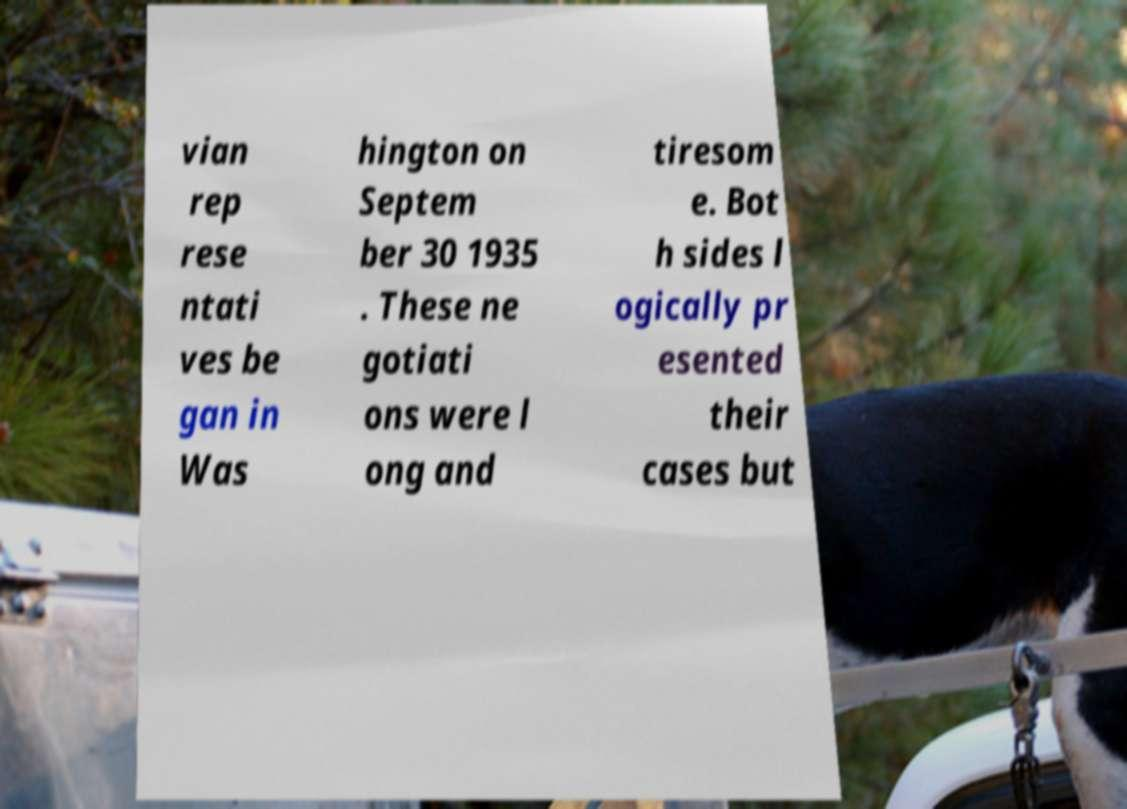Please identify and transcribe the text found in this image. vian rep rese ntati ves be gan in Was hington on Septem ber 30 1935 . These ne gotiati ons were l ong and tiresom e. Bot h sides l ogically pr esented their cases but 